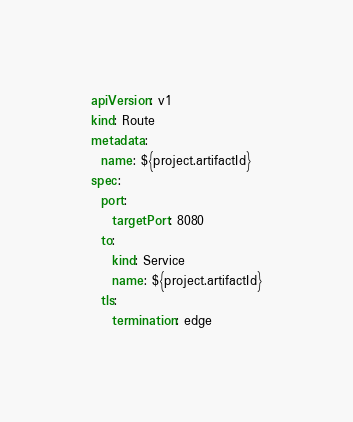Convert code to text. <code><loc_0><loc_0><loc_500><loc_500><_YAML_>apiVersion: v1
kind: Route
metadata:
  name: ${project.artifactId}
spec:
  port:
    targetPort: 8080
  to:
    kind: Service
    name: ${project.artifactId}
  tls:
    termination: edge
</code> 